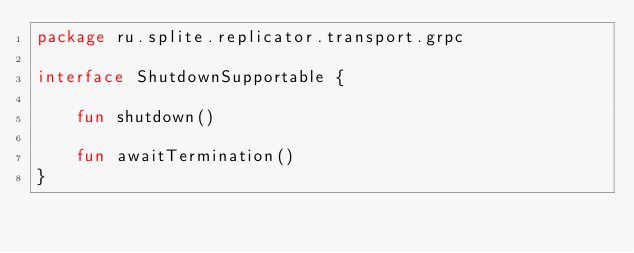<code> <loc_0><loc_0><loc_500><loc_500><_Kotlin_>package ru.splite.replicator.transport.grpc

interface ShutdownSupportable {

    fun shutdown()

    fun awaitTermination()
}</code> 